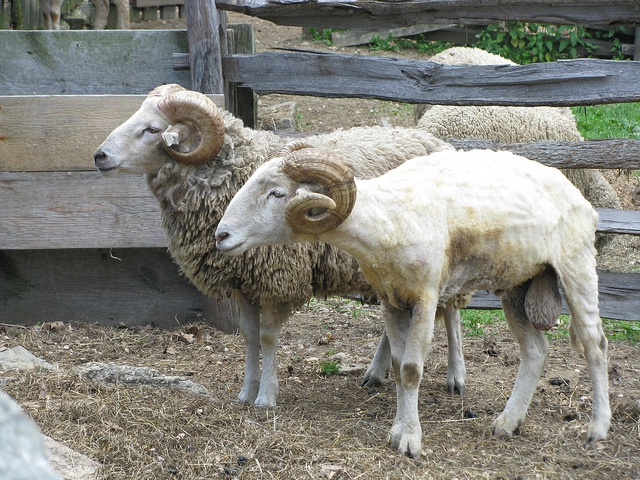Describe the objects in this image and their specific colors. I can see sheep in gray, white, and darkgray tones, sheep in gray, lightgray, darkgray, and black tones, and sheep in gray, lightgray, and darkgray tones in this image. 